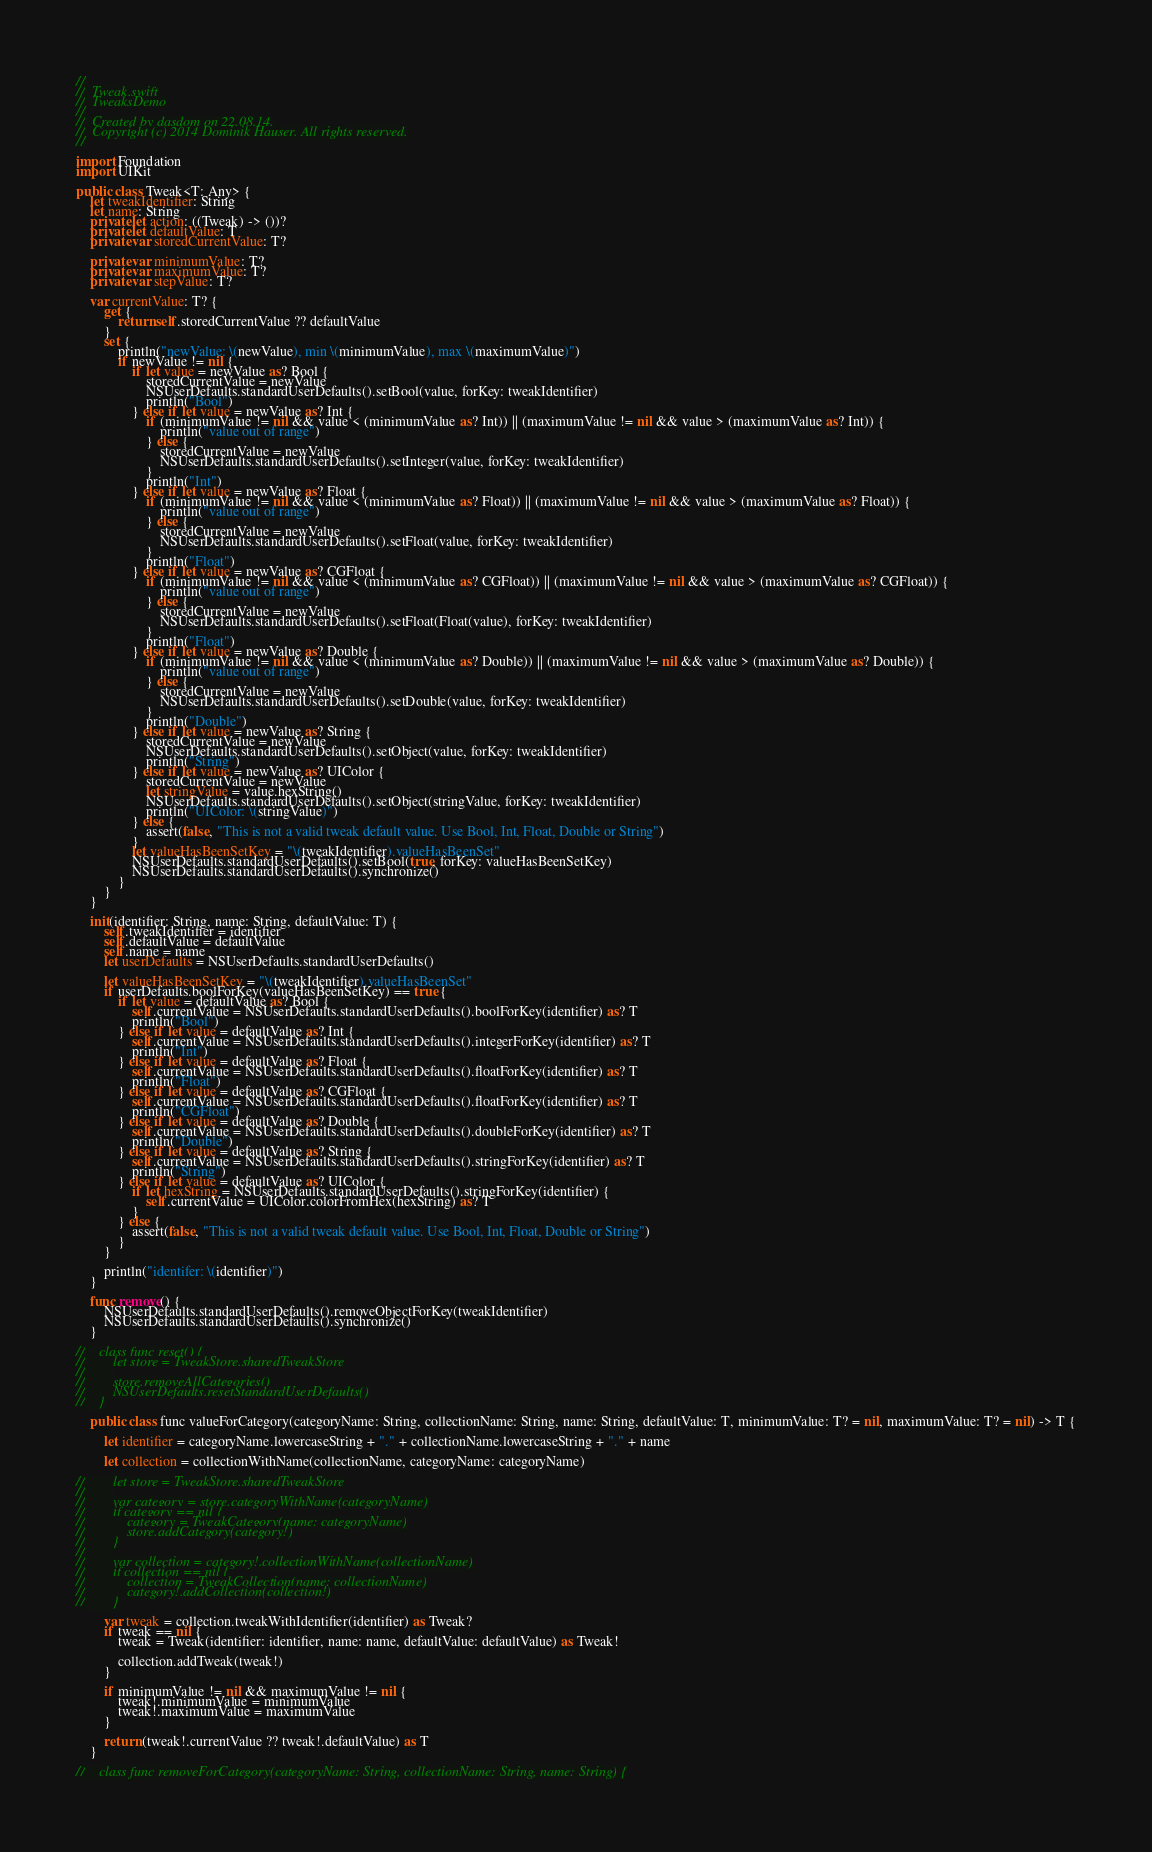<code> <loc_0><loc_0><loc_500><loc_500><_Swift_>//
//  Tweak.swift
//  TweaksDemo
//
//  Created by dasdom on 22.08.14.
//  Copyright (c) 2014 Dominik Hauser. All rights reserved.
//

import Foundation
import UIKit

public class Tweak<T: Any> {
    let tweakIdentifier: String
    let name: String
    private let action: ((Tweak) -> ())?
    private let defaultValue: T
    private var storedCurrentValue: T?
    
    private var minimumValue: T?
    private var maximumValue: T?
    private var stepValue: T?
    
    var currentValue: T? {
        get {
            return self.storedCurrentValue ?? defaultValue
        }
        set {
            println("newValue: \(newValue), min \(minimumValue), max \(maximumValue)")
            if newValue != nil {
                if let value = newValue as? Bool {
                    storedCurrentValue = newValue
                    NSUserDefaults.standardUserDefaults().setBool(value, forKey: tweakIdentifier)
                    println("Bool")
                } else if let value = newValue as? Int {
                    if (minimumValue != nil && value < (minimumValue as? Int)) || (maximumValue != nil && value > (maximumValue as? Int)) {
                        println("value out of range")
                    } else {
                        storedCurrentValue = newValue
                        NSUserDefaults.standardUserDefaults().setInteger(value, forKey: tweakIdentifier)
                    }
                    println("Int")
                } else if let value = newValue as? Float {
                    if (minimumValue != nil && value < (minimumValue as? Float)) || (maximumValue != nil && value > (maximumValue as? Float)) {
                        println("value out of range")
                    } else {
                        storedCurrentValue = newValue
                        NSUserDefaults.standardUserDefaults().setFloat(value, forKey: tweakIdentifier)
                    }
                    println("Float")
                } else if let value = newValue as? CGFloat {
                    if (minimumValue != nil && value < (minimumValue as? CGFloat)) || (maximumValue != nil && value > (maximumValue as? CGFloat)) {
                        println("value out of range")
                    } else {
                        storedCurrentValue = newValue
                        NSUserDefaults.standardUserDefaults().setFloat(Float(value), forKey: tweakIdentifier)
                    }
                    println("Float")
                } else if let value = newValue as? Double {
                    if (minimumValue != nil && value < (minimumValue as? Double)) || (maximumValue != nil && value > (maximumValue as? Double)) {
                        println("value out of range")
                    } else {
                        storedCurrentValue = newValue
                        NSUserDefaults.standardUserDefaults().setDouble(value, forKey: tweakIdentifier)
                    }
                    println("Double")
                } else if let value = newValue as? String {
                    storedCurrentValue = newValue
                    NSUserDefaults.standardUserDefaults().setObject(value, forKey: tweakIdentifier)
                    println("String")
                } else if let value = newValue as? UIColor {
                    storedCurrentValue = newValue
                    let stringValue = value.hexString()
                    NSUserDefaults.standardUserDefaults().setObject(stringValue, forKey: tweakIdentifier)
                    println("UIColor: \(stringValue)")
                } else {
                    assert(false, "This is not a valid tweak default value. Use Bool, Int, Float, Double or String")
                }
                let valueHasBeenSetKey = "\(tweakIdentifier).valueHasBeenSet"
                NSUserDefaults.standardUserDefaults().setBool(true, forKey: valueHasBeenSetKey)
                NSUserDefaults.standardUserDefaults().synchronize()
            }
        }
    }
    
    init(identifier: String, name: String, defaultValue: T) {
        self.tweakIdentifier = identifier
        self.defaultValue = defaultValue
        self.name = name
        let userDefaults = NSUserDefaults.standardUserDefaults()
        
        let valueHasBeenSetKey = "\(tweakIdentifier).valueHasBeenSet"
        if userDefaults.boolForKey(valueHasBeenSetKey) == true {
            if let value = defaultValue as? Bool {
                self.currentValue = NSUserDefaults.standardUserDefaults().boolForKey(identifier) as? T
                println("Bool")
            } else if let value = defaultValue as? Int {
                self.currentValue = NSUserDefaults.standardUserDefaults().integerForKey(identifier) as? T
                println("Int")
            } else if let value = defaultValue as? Float {
                self.currentValue = NSUserDefaults.standardUserDefaults().floatForKey(identifier) as? T
                println("Float")
            } else if let value = defaultValue as? CGFloat {
                self.currentValue = NSUserDefaults.standardUserDefaults().floatForKey(identifier) as? T
                println("CGFloat")
            } else if let value = defaultValue as? Double {
                self.currentValue = NSUserDefaults.standardUserDefaults().doubleForKey(identifier) as? T
                println("Double")
            } else if let value = defaultValue as? String {
                self.currentValue = NSUserDefaults.standardUserDefaults().stringForKey(identifier) as? T
                println("String")
            } else if let value = defaultValue as? UIColor {
                if let hexString = NSUserDefaults.standardUserDefaults().stringForKey(identifier) {
                    self.currentValue = UIColor.colorFromHex(hexString) as? T
                }
            } else {
                assert(false, "This is not a valid tweak default value. Use Bool, Int, Float, Double or String")
            }
        }

        println("identifer: \(identifier)")
    }
    
    func remove() {
        NSUserDefaults.standardUserDefaults().removeObjectForKey(tweakIdentifier)
        NSUserDefaults.standardUserDefaults().synchronize()
    }
    
//    class func reset() {
//        let store = TweakStore.sharedTweakStore
//        
//        store.removeAllCategories()
//        NSUserDefaults.resetStandardUserDefaults()
//    }

    public class func valueForCategory(categoryName: String, collectionName: String, name: String, defaultValue: T, minimumValue: T? = nil, maximumValue: T? = nil) -> T {
        
        let identifier = categoryName.lowercaseString + "." + collectionName.lowercaseString + "." + name
        
        let collection = collectionWithName(collectionName, categoryName: categoryName)
        
//        let store = TweakStore.sharedTweakStore
//        
//        var category = store.categoryWithName(categoryName)
//        if category == nil {
//            category = TweakCategory(name: categoryName)
//            store.addCategory(category!)
//        }
//        
//        var collection = category!.collectionWithName(collectionName)
//        if collection == nil {
//            collection = TweakCollection(name: collectionName)
//            category!.addCollection(collection!)
//        }
        
        var tweak = collection.tweakWithIdentifier(identifier) as Tweak?
        if tweak == nil {
            tweak = Tweak(identifier: identifier, name: name, defaultValue: defaultValue) as Tweak!
            
            collection.addTweak(tweak!)
        }
        
        if minimumValue != nil && maximumValue != nil {
            tweak!.minimumValue = minimumValue
            tweak!.maximumValue = maximumValue
        }
        
        return (tweak!.currentValue ?? tweak!.defaultValue) as T
    }
    
//    class func removeForCategory(categoryName: String, collectionName: String, name: String) {</code> 